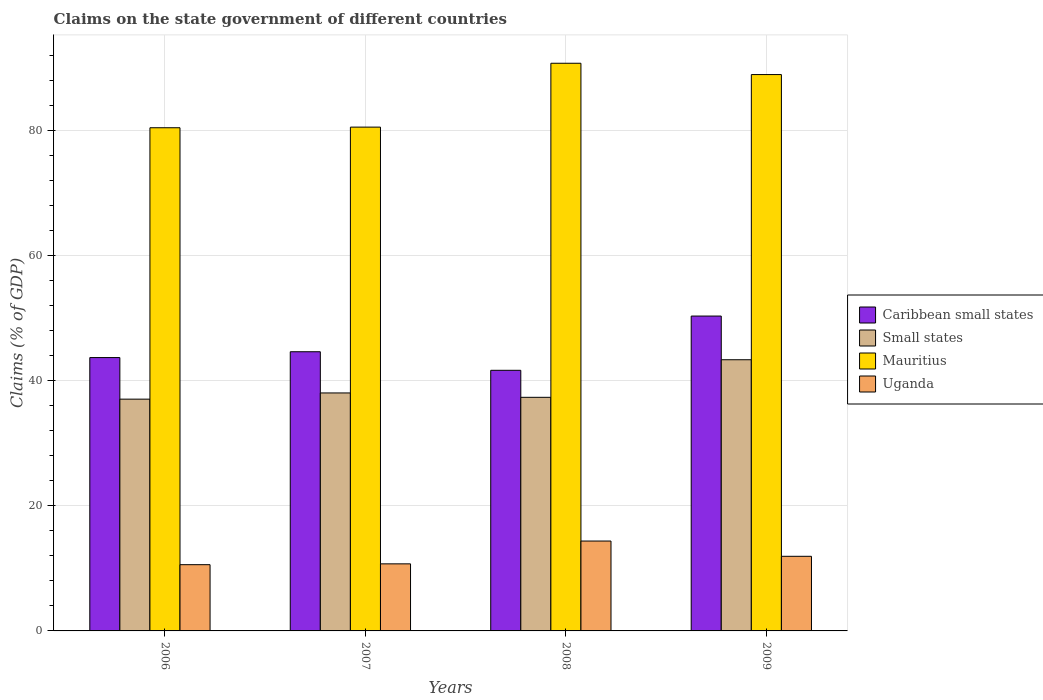How many different coloured bars are there?
Provide a succinct answer. 4. Are the number of bars per tick equal to the number of legend labels?
Offer a terse response. Yes. Are the number of bars on each tick of the X-axis equal?
Offer a terse response. Yes. What is the percentage of GDP claimed on the state government in Caribbean small states in 2008?
Offer a very short reply. 41.7. Across all years, what is the maximum percentage of GDP claimed on the state government in Caribbean small states?
Your response must be concise. 50.38. Across all years, what is the minimum percentage of GDP claimed on the state government in Caribbean small states?
Provide a short and direct response. 41.7. In which year was the percentage of GDP claimed on the state government in Uganda maximum?
Offer a terse response. 2008. In which year was the percentage of GDP claimed on the state government in Mauritius minimum?
Your answer should be compact. 2006. What is the total percentage of GDP claimed on the state government in Uganda in the graph?
Make the answer very short. 47.65. What is the difference between the percentage of GDP claimed on the state government in Small states in 2006 and that in 2007?
Give a very brief answer. -0.99. What is the difference between the percentage of GDP claimed on the state government in Mauritius in 2009 and the percentage of GDP claimed on the state government in Uganda in 2006?
Your response must be concise. 78.41. What is the average percentage of GDP claimed on the state government in Small states per year?
Make the answer very short. 38.98. In the year 2007, what is the difference between the percentage of GDP claimed on the state government in Uganda and percentage of GDP claimed on the state government in Mauritius?
Provide a succinct answer. -69.87. What is the ratio of the percentage of GDP claimed on the state government in Uganda in 2006 to that in 2007?
Your answer should be very brief. 0.99. Is the percentage of GDP claimed on the state government in Mauritius in 2008 less than that in 2009?
Give a very brief answer. No. Is the difference between the percentage of GDP claimed on the state government in Uganda in 2008 and 2009 greater than the difference between the percentage of GDP claimed on the state government in Mauritius in 2008 and 2009?
Your response must be concise. Yes. What is the difference between the highest and the second highest percentage of GDP claimed on the state government in Mauritius?
Your answer should be very brief. 1.81. What is the difference between the highest and the lowest percentage of GDP claimed on the state government in Mauritius?
Provide a succinct answer. 10.32. Is it the case that in every year, the sum of the percentage of GDP claimed on the state government in Mauritius and percentage of GDP claimed on the state government in Uganda is greater than the sum of percentage of GDP claimed on the state government in Caribbean small states and percentage of GDP claimed on the state government in Small states?
Ensure brevity in your answer.  No. What does the 4th bar from the left in 2006 represents?
Your answer should be compact. Uganda. What does the 2nd bar from the right in 2008 represents?
Provide a short and direct response. Mauritius. How many bars are there?
Your answer should be compact. 16. What is the difference between two consecutive major ticks on the Y-axis?
Ensure brevity in your answer.  20. Are the values on the major ticks of Y-axis written in scientific E-notation?
Your response must be concise. No. Does the graph contain any zero values?
Your answer should be very brief. No. How many legend labels are there?
Offer a very short reply. 4. How are the legend labels stacked?
Provide a short and direct response. Vertical. What is the title of the graph?
Keep it short and to the point. Claims on the state government of different countries. What is the label or title of the X-axis?
Your answer should be very brief. Years. What is the label or title of the Y-axis?
Offer a very short reply. Claims (% of GDP). What is the Claims (% of GDP) in Caribbean small states in 2006?
Your response must be concise. 43.73. What is the Claims (% of GDP) of Small states in 2006?
Your answer should be very brief. 37.08. What is the Claims (% of GDP) in Mauritius in 2006?
Keep it short and to the point. 80.5. What is the Claims (% of GDP) of Uganda in 2006?
Your answer should be compact. 10.6. What is the Claims (% of GDP) of Caribbean small states in 2007?
Give a very brief answer. 44.67. What is the Claims (% of GDP) of Small states in 2007?
Provide a succinct answer. 38.07. What is the Claims (% of GDP) of Mauritius in 2007?
Offer a very short reply. 80.6. What is the Claims (% of GDP) of Uganda in 2007?
Your answer should be very brief. 10.73. What is the Claims (% of GDP) of Caribbean small states in 2008?
Keep it short and to the point. 41.7. What is the Claims (% of GDP) of Small states in 2008?
Provide a short and direct response. 37.37. What is the Claims (% of GDP) in Mauritius in 2008?
Your answer should be compact. 90.82. What is the Claims (% of GDP) in Uganda in 2008?
Offer a terse response. 14.38. What is the Claims (% of GDP) in Caribbean small states in 2009?
Provide a succinct answer. 50.38. What is the Claims (% of GDP) of Small states in 2009?
Provide a short and direct response. 43.38. What is the Claims (% of GDP) of Mauritius in 2009?
Your answer should be very brief. 89.01. What is the Claims (% of GDP) in Uganda in 2009?
Make the answer very short. 11.94. Across all years, what is the maximum Claims (% of GDP) in Caribbean small states?
Keep it short and to the point. 50.38. Across all years, what is the maximum Claims (% of GDP) of Small states?
Keep it short and to the point. 43.38. Across all years, what is the maximum Claims (% of GDP) in Mauritius?
Provide a short and direct response. 90.82. Across all years, what is the maximum Claims (% of GDP) of Uganda?
Your answer should be very brief. 14.38. Across all years, what is the minimum Claims (% of GDP) in Caribbean small states?
Ensure brevity in your answer.  41.7. Across all years, what is the minimum Claims (% of GDP) in Small states?
Give a very brief answer. 37.08. Across all years, what is the minimum Claims (% of GDP) of Mauritius?
Offer a very short reply. 80.5. Across all years, what is the minimum Claims (% of GDP) in Uganda?
Ensure brevity in your answer.  10.6. What is the total Claims (% of GDP) in Caribbean small states in the graph?
Keep it short and to the point. 180.47. What is the total Claims (% of GDP) of Small states in the graph?
Offer a very short reply. 155.91. What is the total Claims (% of GDP) of Mauritius in the graph?
Keep it short and to the point. 340.93. What is the total Claims (% of GDP) in Uganda in the graph?
Provide a short and direct response. 47.65. What is the difference between the Claims (% of GDP) in Caribbean small states in 2006 and that in 2007?
Offer a very short reply. -0.93. What is the difference between the Claims (% of GDP) of Small states in 2006 and that in 2007?
Offer a very short reply. -0.99. What is the difference between the Claims (% of GDP) of Mauritius in 2006 and that in 2007?
Offer a terse response. -0.1. What is the difference between the Claims (% of GDP) in Uganda in 2006 and that in 2007?
Give a very brief answer. -0.13. What is the difference between the Claims (% of GDP) in Caribbean small states in 2006 and that in 2008?
Make the answer very short. 2.04. What is the difference between the Claims (% of GDP) in Small states in 2006 and that in 2008?
Keep it short and to the point. -0.29. What is the difference between the Claims (% of GDP) in Mauritius in 2006 and that in 2008?
Provide a succinct answer. -10.32. What is the difference between the Claims (% of GDP) of Uganda in 2006 and that in 2008?
Offer a terse response. -3.78. What is the difference between the Claims (% of GDP) of Caribbean small states in 2006 and that in 2009?
Make the answer very short. -6.64. What is the difference between the Claims (% of GDP) in Small states in 2006 and that in 2009?
Make the answer very short. -6.3. What is the difference between the Claims (% of GDP) of Mauritius in 2006 and that in 2009?
Offer a terse response. -8.51. What is the difference between the Claims (% of GDP) of Uganda in 2006 and that in 2009?
Offer a terse response. -1.34. What is the difference between the Claims (% of GDP) in Caribbean small states in 2007 and that in 2008?
Your answer should be very brief. 2.97. What is the difference between the Claims (% of GDP) in Small states in 2007 and that in 2008?
Your answer should be compact. 0.7. What is the difference between the Claims (% of GDP) of Mauritius in 2007 and that in 2008?
Your answer should be compact. -10.22. What is the difference between the Claims (% of GDP) of Uganda in 2007 and that in 2008?
Make the answer very short. -3.65. What is the difference between the Claims (% of GDP) in Caribbean small states in 2007 and that in 2009?
Ensure brevity in your answer.  -5.71. What is the difference between the Claims (% of GDP) of Small states in 2007 and that in 2009?
Make the answer very short. -5.31. What is the difference between the Claims (% of GDP) in Mauritius in 2007 and that in 2009?
Provide a short and direct response. -8.41. What is the difference between the Claims (% of GDP) of Uganda in 2007 and that in 2009?
Give a very brief answer. -1.21. What is the difference between the Claims (% of GDP) in Caribbean small states in 2008 and that in 2009?
Make the answer very short. -8.68. What is the difference between the Claims (% of GDP) of Small states in 2008 and that in 2009?
Offer a very short reply. -6.01. What is the difference between the Claims (% of GDP) in Mauritius in 2008 and that in 2009?
Offer a very short reply. 1.81. What is the difference between the Claims (% of GDP) of Uganda in 2008 and that in 2009?
Your answer should be compact. 2.44. What is the difference between the Claims (% of GDP) of Caribbean small states in 2006 and the Claims (% of GDP) of Small states in 2007?
Offer a terse response. 5.66. What is the difference between the Claims (% of GDP) of Caribbean small states in 2006 and the Claims (% of GDP) of Mauritius in 2007?
Provide a succinct answer. -36.87. What is the difference between the Claims (% of GDP) in Caribbean small states in 2006 and the Claims (% of GDP) in Uganda in 2007?
Keep it short and to the point. 33. What is the difference between the Claims (% of GDP) in Small states in 2006 and the Claims (% of GDP) in Mauritius in 2007?
Offer a very short reply. -43.52. What is the difference between the Claims (% of GDP) in Small states in 2006 and the Claims (% of GDP) in Uganda in 2007?
Keep it short and to the point. 26.35. What is the difference between the Claims (% of GDP) of Mauritius in 2006 and the Claims (% of GDP) of Uganda in 2007?
Give a very brief answer. 69.77. What is the difference between the Claims (% of GDP) of Caribbean small states in 2006 and the Claims (% of GDP) of Small states in 2008?
Your response must be concise. 6.36. What is the difference between the Claims (% of GDP) of Caribbean small states in 2006 and the Claims (% of GDP) of Mauritius in 2008?
Offer a very short reply. -47.09. What is the difference between the Claims (% of GDP) in Caribbean small states in 2006 and the Claims (% of GDP) in Uganda in 2008?
Offer a terse response. 29.35. What is the difference between the Claims (% of GDP) in Small states in 2006 and the Claims (% of GDP) in Mauritius in 2008?
Your response must be concise. -53.74. What is the difference between the Claims (% of GDP) of Small states in 2006 and the Claims (% of GDP) of Uganda in 2008?
Offer a very short reply. 22.7. What is the difference between the Claims (% of GDP) of Mauritius in 2006 and the Claims (% of GDP) of Uganda in 2008?
Make the answer very short. 66.12. What is the difference between the Claims (% of GDP) in Caribbean small states in 2006 and the Claims (% of GDP) in Small states in 2009?
Give a very brief answer. 0.35. What is the difference between the Claims (% of GDP) in Caribbean small states in 2006 and the Claims (% of GDP) in Mauritius in 2009?
Provide a short and direct response. -45.28. What is the difference between the Claims (% of GDP) in Caribbean small states in 2006 and the Claims (% of GDP) in Uganda in 2009?
Your answer should be very brief. 31.8. What is the difference between the Claims (% of GDP) in Small states in 2006 and the Claims (% of GDP) in Mauritius in 2009?
Keep it short and to the point. -51.93. What is the difference between the Claims (% of GDP) of Small states in 2006 and the Claims (% of GDP) of Uganda in 2009?
Make the answer very short. 25.14. What is the difference between the Claims (% of GDP) in Mauritius in 2006 and the Claims (% of GDP) in Uganda in 2009?
Your response must be concise. 68.56. What is the difference between the Claims (% of GDP) in Caribbean small states in 2007 and the Claims (% of GDP) in Small states in 2008?
Your answer should be very brief. 7.29. What is the difference between the Claims (% of GDP) in Caribbean small states in 2007 and the Claims (% of GDP) in Mauritius in 2008?
Your response must be concise. -46.15. What is the difference between the Claims (% of GDP) in Caribbean small states in 2007 and the Claims (% of GDP) in Uganda in 2008?
Your response must be concise. 30.28. What is the difference between the Claims (% of GDP) in Small states in 2007 and the Claims (% of GDP) in Mauritius in 2008?
Ensure brevity in your answer.  -52.75. What is the difference between the Claims (% of GDP) of Small states in 2007 and the Claims (% of GDP) of Uganda in 2008?
Your response must be concise. 23.69. What is the difference between the Claims (% of GDP) in Mauritius in 2007 and the Claims (% of GDP) in Uganda in 2008?
Make the answer very short. 66.22. What is the difference between the Claims (% of GDP) of Caribbean small states in 2007 and the Claims (% of GDP) of Small states in 2009?
Provide a succinct answer. 1.28. What is the difference between the Claims (% of GDP) in Caribbean small states in 2007 and the Claims (% of GDP) in Mauritius in 2009?
Provide a short and direct response. -44.34. What is the difference between the Claims (% of GDP) in Caribbean small states in 2007 and the Claims (% of GDP) in Uganda in 2009?
Your response must be concise. 32.73. What is the difference between the Claims (% of GDP) in Small states in 2007 and the Claims (% of GDP) in Mauritius in 2009?
Offer a very short reply. -50.94. What is the difference between the Claims (% of GDP) of Small states in 2007 and the Claims (% of GDP) of Uganda in 2009?
Ensure brevity in your answer.  26.14. What is the difference between the Claims (% of GDP) of Mauritius in 2007 and the Claims (% of GDP) of Uganda in 2009?
Keep it short and to the point. 68.66. What is the difference between the Claims (% of GDP) of Caribbean small states in 2008 and the Claims (% of GDP) of Small states in 2009?
Your response must be concise. -1.69. What is the difference between the Claims (% of GDP) of Caribbean small states in 2008 and the Claims (% of GDP) of Mauritius in 2009?
Your answer should be very brief. -47.31. What is the difference between the Claims (% of GDP) in Caribbean small states in 2008 and the Claims (% of GDP) in Uganda in 2009?
Your answer should be compact. 29.76. What is the difference between the Claims (% of GDP) in Small states in 2008 and the Claims (% of GDP) in Mauritius in 2009?
Your answer should be compact. -51.64. What is the difference between the Claims (% of GDP) in Small states in 2008 and the Claims (% of GDP) in Uganda in 2009?
Provide a succinct answer. 25.43. What is the difference between the Claims (% of GDP) in Mauritius in 2008 and the Claims (% of GDP) in Uganda in 2009?
Make the answer very short. 78.88. What is the average Claims (% of GDP) of Caribbean small states per year?
Your answer should be compact. 45.12. What is the average Claims (% of GDP) in Small states per year?
Provide a succinct answer. 38.98. What is the average Claims (% of GDP) of Mauritius per year?
Keep it short and to the point. 85.23. What is the average Claims (% of GDP) in Uganda per year?
Ensure brevity in your answer.  11.91. In the year 2006, what is the difference between the Claims (% of GDP) in Caribbean small states and Claims (% of GDP) in Small states?
Your answer should be compact. 6.65. In the year 2006, what is the difference between the Claims (% of GDP) of Caribbean small states and Claims (% of GDP) of Mauritius?
Offer a terse response. -36.77. In the year 2006, what is the difference between the Claims (% of GDP) of Caribbean small states and Claims (% of GDP) of Uganda?
Provide a succinct answer. 33.14. In the year 2006, what is the difference between the Claims (% of GDP) in Small states and Claims (% of GDP) in Mauritius?
Your response must be concise. -43.42. In the year 2006, what is the difference between the Claims (% of GDP) of Small states and Claims (% of GDP) of Uganda?
Ensure brevity in your answer.  26.48. In the year 2006, what is the difference between the Claims (% of GDP) in Mauritius and Claims (% of GDP) in Uganda?
Offer a very short reply. 69.9. In the year 2007, what is the difference between the Claims (% of GDP) of Caribbean small states and Claims (% of GDP) of Small states?
Your response must be concise. 6.59. In the year 2007, what is the difference between the Claims (% of GDP) in Caribbean small states and Claims (% of GDP) in Mauritius?
Provide a succinct answer. -35.94. In the year 2007, what is the difference between the Claims (% of GDP) of Caribbean small states and Claims (% of GDP) of Uganda?
Ensure brevity in your answer.  33.93. In the year 2007, what is the difference between the Claims (% of GDP) of Small states and Claims (% of GDP) of Mauritius?
Offer a very short reply. -42.53. In the year 2007, what is the difference between the Claims (% of GDP) in Small states and Claims (% of GDP) in Uganda?
Offer a terse response. 27.34. In the year 2007, what is the difference between the Claims (% of GDP) of Mauritius and Claims (% of GDP) of Uganda?
Your answer should be compact. 69.87. In the year 2008, what is the difference between the Claims (% of GDP) in Caribbean small states and Claims (% of GDP) in Small states?
Give a very brief answer. 4.32. In the year 2008, what is the difference between the Claims (% of GDP) of Caribbean small states and Claims (% of GDP) of Mauritius?
Your answer should be compact. -49.12. In the year 2008, what is the difference between the Claims (% of GDP) in Caribbean small states and Claims (% of GDP) in Uganda?
Provide a succinct answer. 27.32. In the year 2008, what is the difference between the Claims (% of GDP) of Small states and Claims (% of GDP) of Mauritius?
Offer a very short reply. -53.45. In the year 2008, what is the difference between the Claims (% of GDP) in Small states and Claims (% of GDP) in Uganda?
Give a very brief answer. 22.99. In the year 2008, what is the difference between the Claims (% of GDP) of Mauritius and Claims (% of GDP) of Uganda?
Your answer should be very brief. 76.44. In the year 2009, what is the difference between the Claims (% of GDP) of Caribbean small states and Claims (% of GDP) of Small states?
Ensure brevity in your answer.  6.99. In the year 2009, what is the difference between the Claims (% of GDP) in Caribbean small states and Claims (% of GDP) in Mauritius?
Provide a succinct answer. -38.63. In the year 2009, what is the difference between the Claims (% of GDP) in Caribbean small states and Claims (% of GDP) in Uganda?
Provide a short and direct response. 38.44. In the year 2009, what is the difference between the Claims (% of GDP) in Small states and Claims (% of GDP) in Mauritius?
Provide a succinct answer. -45.63. In the year 2009, what is the difference between the Claims (% of GDP) in Small states and Claims (% of GDP) in Uganda?
Your answer should be compact. 31.45. In the year 2009, what is the difference between the Claims (% of GDP) in Mauritius and Claims (% of GDP) in Uganda?
Give a very brief answer. 77.07. What is the ratio of the Claims (% of GDP) of Caribbean small states in 2006 to that in 2007?
Your answer should be very brief. 0.98. What is the ratio of the Claims (% of GDP) of Small states in 2006 to that in 2007?
Offer a terse response. 0.97. What is the ratio of the Claims (% of GDP) of Uganda in 2006 to that in 2007?
Your answer should be very brief. 0.99. What is the ratio of the Claims (% of GDP) in Caribbean small states in 2006 to that in 2008?
Ensure brevity in your answer.  1.05. What is the ratio of the Claims (% of GDP) of Mauritius in 2006 to that in 2008?
Give a very brief answer. 0.89. What is the ratio of the Claims (% of GDP) in Uganda in 2006 to that in 2008?
Offer a terse response. 0.74. What is the ratio of the Claims (% of GDP) in Caribbean small states in 2006 to that in 2009?
Ensure brevity in your answer.  0.87. What is the ratio of the Claims (% of GDP) in Small states in 2006 to that in 2009?
Your answer should be very brief. 0.85. What is the ratio of the Claims (% of GDP) of Mauritius in 2006 to that in 2009?
Provide a short and direct response. 0.9. What is the ratio of the Claims (% of GDP) of Uganda in 2006 to that in 2009?
Provide a succinct answer. 0.89. What is the ratio of the Claims (% of GDP) of Caribbean small states in 2007 to that in 2008?
Offer a terse response. 1.07. What is the ratio of the Claims (% of GDP) in Small states in 2007 to that in 2008?
Keep it short and to the point. 1.02. What is the ratio of the Claims (% of GDP) of Mauritius in 2007 to that in 2008?
Keep it short and to the point. 0.89. What is the ratio of the Claims (% of GDP) of Uganda in 2007 to that in 2008?
Give a very brief answer. 0.75. What is the ratio of the Claims (% of GDP) of Caribbean small states in 2007 to that in 2009?
Keep it short and to the point. 0.89. What is the ratio of the Claims (% of GDP) of Small states in 2007 to that in 2009?
Provide a short and direct response. 0.88. What is the ratio of the Claims (% of GDP) in Mauritius in 2007 to that in 2009?
Make the answer very short. 0.91. What is the ratio of the Claims (% of GDP) of Uganda in 2007 to that in 2009?
Keep it short and to the point. 0.9. What is the ratio of the Claims (% of GDP) in Caribbean small states in 2008 to that in 2009?
Provide a short and direct response. 0.83. What is the ratio of the Claims (% of GDP) in Small states in 2008 to that in 2009?
Your answer should be compact. 0.86. What is the ratio of the Claims (% of GDP) of Mauritius in 2008 to that in 2009?
Ensure brevity in your answer.  1.02. What is the ratio of the Claims (% of GDP) in Uganda in 2008 to that in 2009?
Your response must be concise. 1.2. What is the difference between the highest and the second highest Claims (% of GDP) of Caribbean small states?
Offer a terse response. 5.71. What is the difference between the highest and the second highest Claims (% of GDP) of Small states?
Provide a short and direct response. 5.31. What is the difference between the highest and the second highest Claims (% of GDP) in Mauritius?
Make the answer very short. 1.81. What is the difference between the highest and the second highest Claims (% of GDP) of Uganda?
Provide a succinct answer. 2.44. What is the difference between the highest and the lowest Claims (% of GDP) of Caribbean small states?
Your answer should be very brief. 8.68. What is the difference between the highest and the lowest Claims (% of GDP) in Small states?
Keep it short and to the point. 6.3. What is the difference between the highest and the lowest Claims (% of GDP) of Mauritius?
Offer a terse response. 10.32. What is the difference between the highest and the lowest Claims (% of GDP) in Uganda?
Offer a terse response. 3.78. 